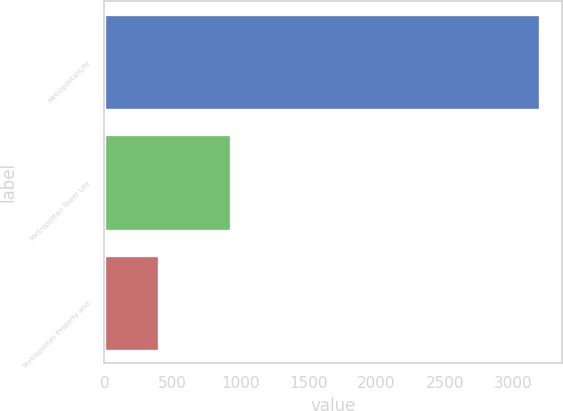<chart> <loc_0><loc_0><loc_500><loc_500><bar_chart><fcel>MetropolitanLife<fcel>Metropolitan Tower Life<fcel>Metropolitan Property and<nl><fcel>3200<fcel>927<fcel>400<nl></chart> 